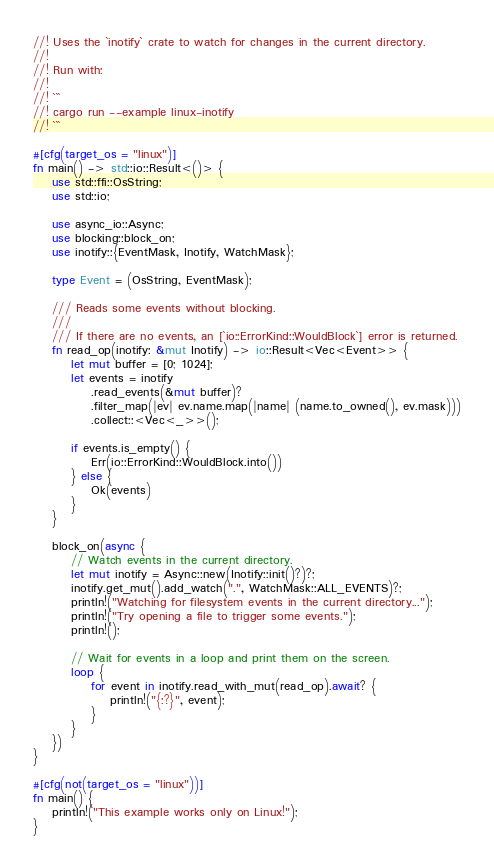Convert code to text. <code><loc_0><loc_0><loc_500><loc_500><_Rust_>//! Uses the `inotify` crate to watch for changes in the current directory.
//!
//! Run with:
//!
//! ```
//! cargo run --example linux-inotify
//! ```

#[cfg(target_os = "linux")]
fn main() -> std::io::Result<()> {
    use std::ffi::OsString;
    use std::io;

    use async_io::Async;
    use blocking::block_on;
    use inotify::{EventMask, Inotify, WatchMask};

    type Event = (OsString, EventMask);

    /// Reads some events without blocking.
    ///
    /// If there are no events, an [`io::ErrorKind::WouldBlock`] error is returned.
    fn read_op(inotify: &mut Inotify) -> io::Result<Vec<Event>> {
        let mut buffer = [0; 1024];
        let events = inotify
            .read_events(&mut buffer)?
            .filter_map(|ev| ev.name.map(|name| (name.to_owned(), ev.mask)))
            .collect::<Vec<_>>();

        if events.is_empty() {
            Err(io::ErrorKind::WouldBlock.into())
        } else {
            Ok(events)
        }
    }

    block_on(async {
        // Watch events in the current directory.
        let mut inotify = Async::new(Inotify::init()?)?;
        inotify.get_mut().add_watch(".", WatchMask::ALL_EVENTS)?;
        println!("Watching for filesystem events in the current directory...");
        println!("Try opening a file to trigger some events.");
        println!();

        // Wait for events in a loop and print them on the screen.
        loop {
            for event in inotify.read_with_mut(read_op).await? {
                println!("{:?}", event);
            }
        }
    })
}

#[cfg(not(target_os = "linux"))]
fn main() {
    println!("This example works only on Linux!");
}
</code> 